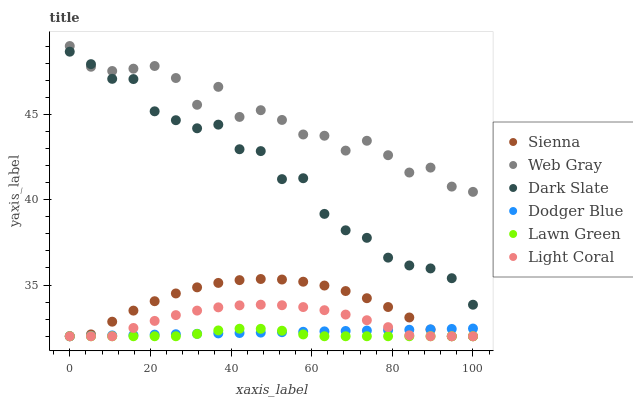Does Lawn Green have the minimum area under the curve?
Answer yes or no. Yes. Does Web Gray have the maximum area under the curve?
Answer yes or no. Yes. Does Web Gray have the minimum area under the curve?
Answer yes or no. No. Does Lawn Green have the maximum area under the curve?
Answer yes or no. No. Is Dodger Blue the smoothest?
Answer yes or no. Yes. Is Web Gray the roughest?
Answer yes or no. Yes. Is Lawn Green the smoothest?
Answer yes or no. No. Is Lawn Green the roughest?
Answer yes or no. No. Does Light Coral have the lowest value?
Answer yes or no. Yes. Does Web Gray have the lowest value?
Answer yes or no. No. Does Web Gray have the highest value?
Answer yes or no. Yes. Does Lawn Green have the highest value?
Answer yes or no. No. Is Light Coral less than Web Gray?
Answer yes or no. Yes. Is Web Gray greater than Lawn Green?
Answer yes or no. Yes. Does Dodger Blue intersect Light Coral?
Answer yes or no. Yes. Is Dodger Blue less than Light Coral?
Answer yes or no. No. Is Dodger Blue greater than Light Coral?
Answer yes or no. No. Does Light Coral intersect Web Gray?
Answer yes or no. No. 